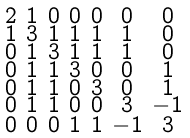<formula> <loc_0><loc_0><loc_500><loc_500>\begin{smallmatrix} 2 & 1 & 0 & 0 & 0 & 0 & 0 \\ 1 & 3 & 1 & 1 & 1 & 1 & 0 \\ 0 & 1 & 3 & 1 & 1 & 1 & 0 \\ 0 & 1 & 1 & 3 & 0 & 0 & 1 \\ 0 & 1 & 1 & 0 & 3 & 0 & 1 \\ 0 & 1 & 1 & 0 & 0 & 3 & - 1 \\ 0 & 0 & 0 & 1 & 1 & - 1 & 3 \end{smallmatrix}</formula> 